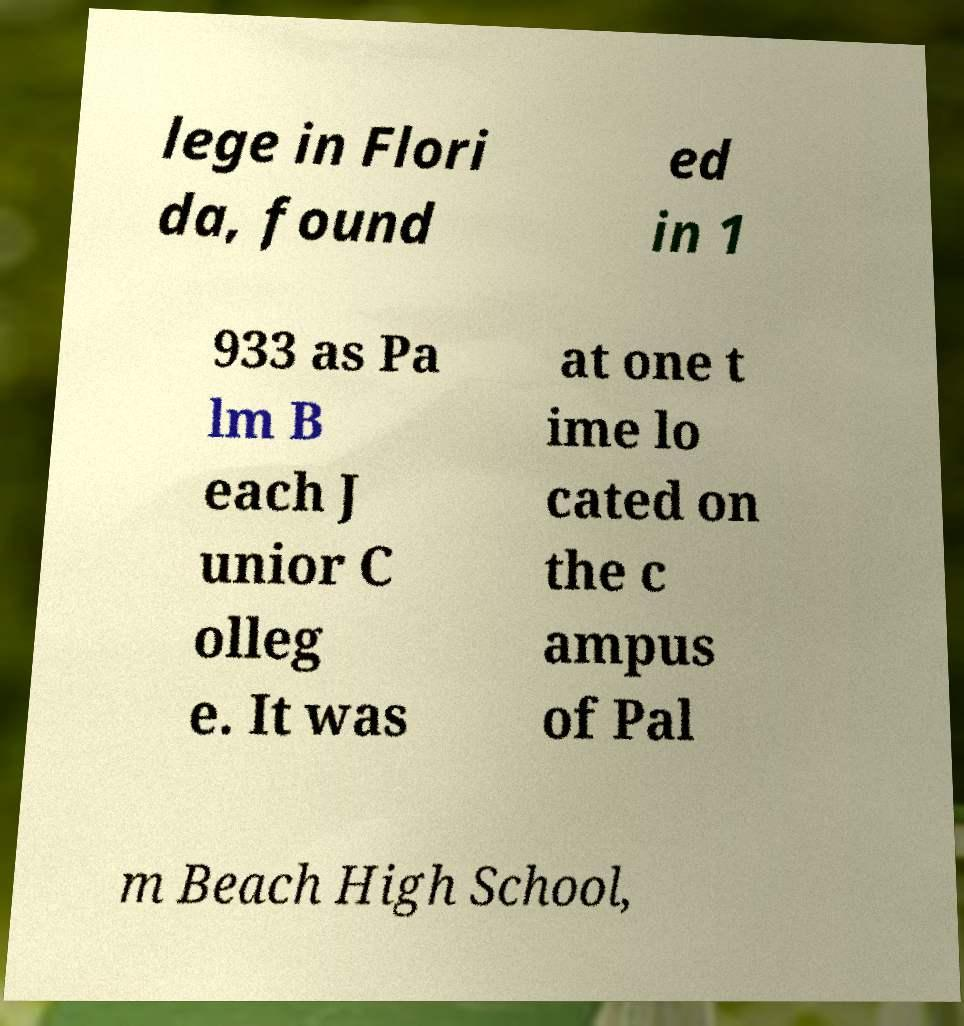Please identify and transcribe the text found in this image. lege in Flori da, found ed in 1 933 as Pa lm B each J unior C olleg e. It was at one t ime lo cated on the c ampus of Pal m Beach High School, 